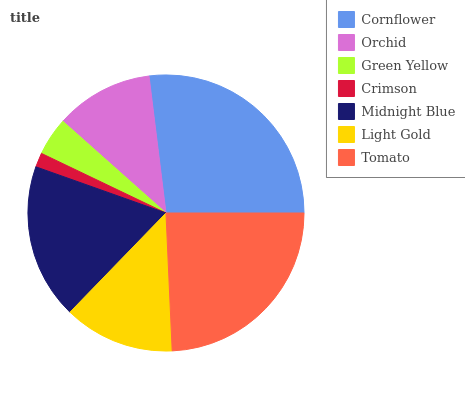Is Crimson the minimum?
Answer yes or no. Yes. Is Cornflower the maximum?
Answer yes or no. Yes. Is Orchid the minimum?
Answer yes or no. No. Is Orchid the maximum?
Answer yes or no. No. Is Cornflower greater than Orchid?
Answer yes or no. Yes. Is Orchid less than Cornflower?
Answer yes or no. Yes. Is Orchid greater than Cornflower?
Answer yes or no. No. Is Cornflower less than Orchid?
Answer yes or no. No. Is Light Gold the high median?
Answer yes or no. Yes. Is Light Gold the low median?
Answer yes or no. Yes. Is Crimson the high median?
Answer yes or no. No. Is Tomato the low median?
Answer yes or no. No. 